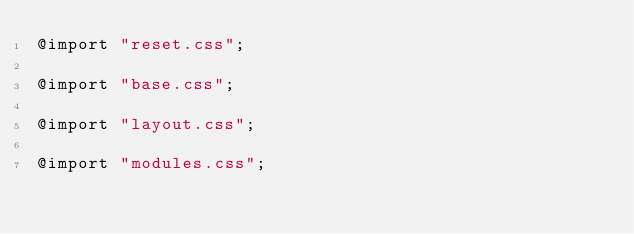Convert code to text. <code><loc_0><loc_0><loc_500><loc_500><_CSS_>@import "reset.css";

@import "base.css";

@import "layout.css";

@import "modules.css";</code> 